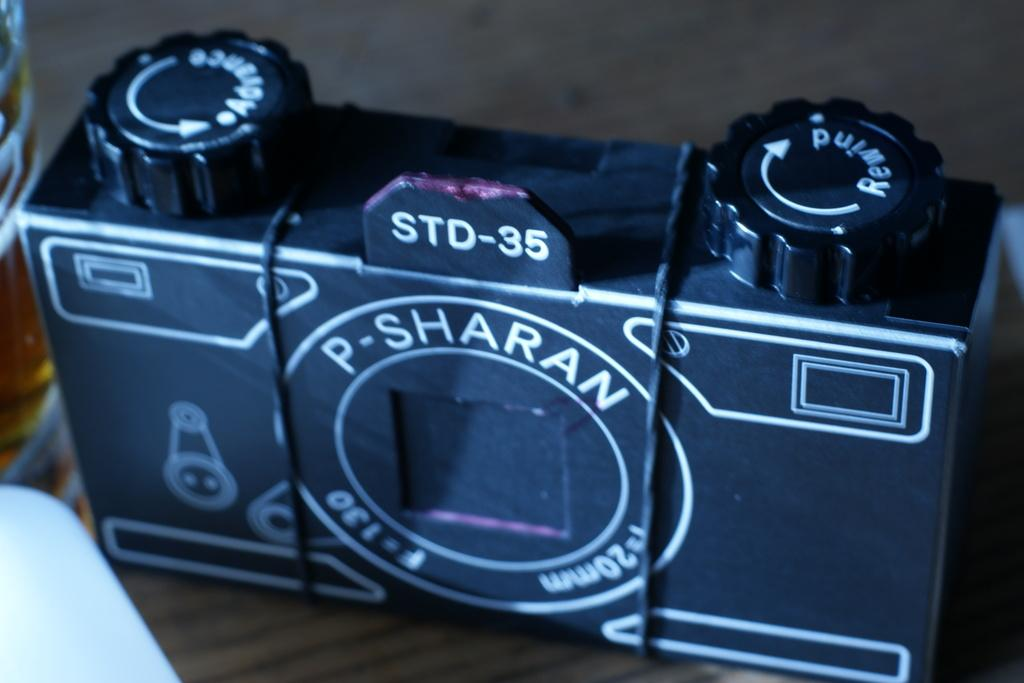<image>
Write a terse but informative summary of the picture. the letter P that is followed by Sharan on a camera 